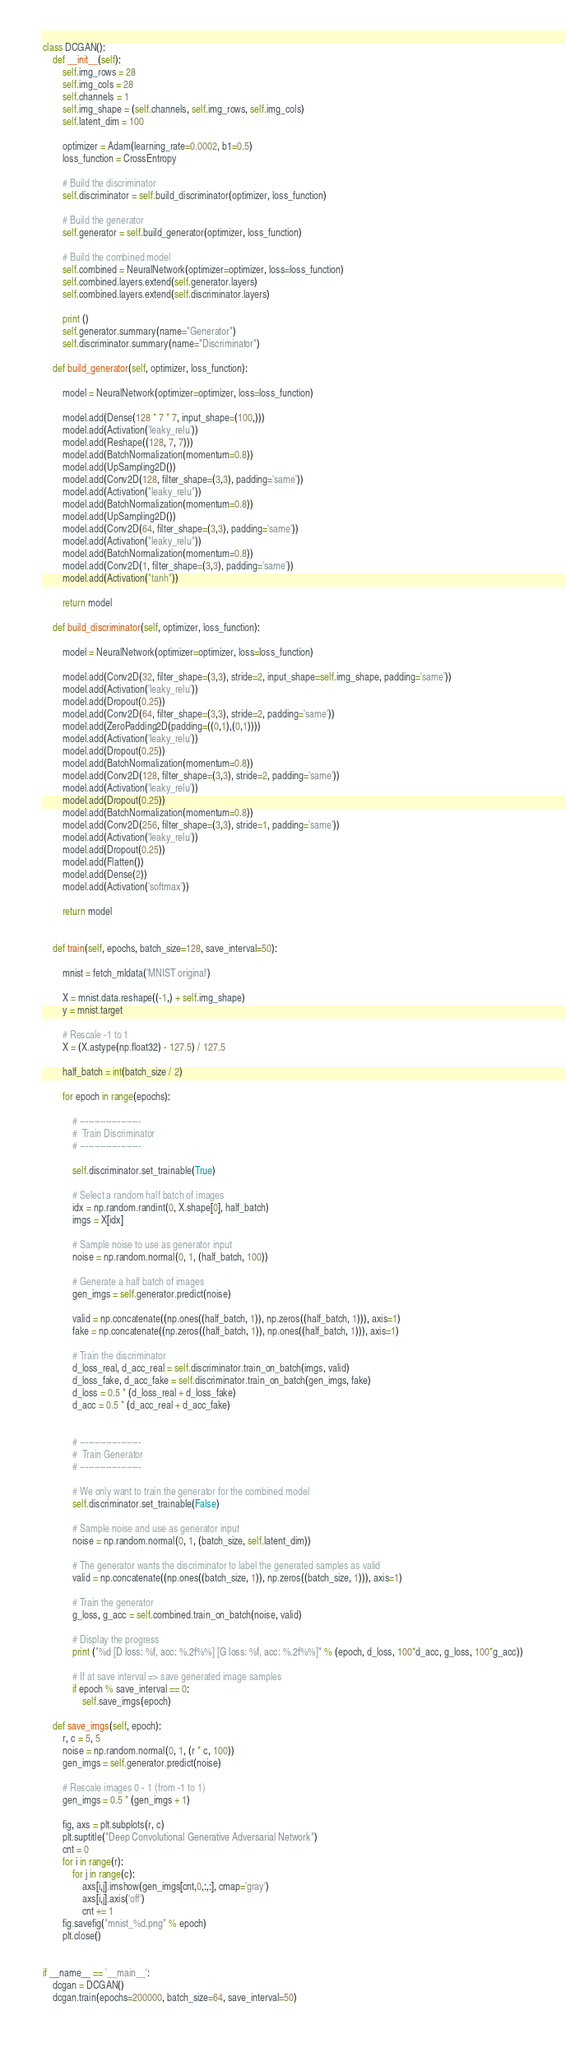Convert code to text. <code><loc_0><loc_0><loc_500><loc_500><_Python_>

class DCGAN():
    def __init__(self):
        self.img_rows = 28 
        self.img_cols = 28
        self.channels = 1
        self.img_shape = (self.channels, self.img_rows, self.img_cols)
        self.latent_dim = 100

        optimizer = Adam(learning_rate=0.0002, b1=0.5)
        loss_function = CrossEntropy

        # Build the discriminator
        self.discriminator = self.build_discriminator(optimizer, loss_function)

        # Build the generator
        self.generator = self.build_generator(optimizer, loss_function)

        # Build the combined model
        self.combined = NeuralNetwork(optimizer=optimizer, loss=loss_function)
        self.combined.layers.extend(self.generator.layers)
        self.combined.layers.extend(self.discriminator.layers)

        print ()
        self.generator.summary(name="Generator")
        self.discriminator.summary(name="Discriminator")

    def build_generator(self, optimizer, loss_function):
        
        model = NeuralNetwork(optimizer=optimizer, loss=loss_function)

        model.add(Dense(128 * 7 * 7, input_shape=(100,)))
        model.add(Activation('leaky_relu'))
        model.add(Reshape((128, 7, 7)))
        model.add(BatchNormalization(momentum=0.8))
        model.add(UpSampling2D())
        model.add(Conv2D(128, filter_shape=(3,3), padding='same'))
        model.add(Activation("leaky_relu"))
        model.add(BatchNormalization(momentum=0.8))
        model.add(UpSampling2D())
        model.add(Conv2D(64, filter_shape=(3,3), padding='same'))
        model.add(Activation("leaky_relu"))
        model.add(BatchNormalization(momentum=0.8))
        model.add(Conv2D(1, filter_shape=(3,3), padding='same'))
        model.add(Activation("tanh"))

        return model

    def build_discriminator(self, optimizer, loss_function):
        
        model = NeuralNetwork(optimizer=optimizer, loss=loss_function)

        model.add(Conv2D(32, filter_shape=(3,3), stride=2, input_shape=self.img_shape, padding='same'))
        model.add(Activation('leaky_relu'))
        model.add(Dropout(0.25))
        model.add(Conv2D(64, filter_shape=(3,3), stride=2, padding='same'))
        model.add(ZeroPadding2D(padding=((0,1),(0,1))))
        model.add(Activation('leaky_relu'))
        model.add(Dropout(0.25))
        model.add(BatchNormalization(momentum=0.8))
        model.add(Conv2D(128, filter_shape=(3,3), stride=2, padding='same'))
        model.add(Activation('leaky_relu'))
        model.add(Dropout(0.25))
        model.add(BatchNormalization(momentum=0.8))
        model.add(Conv2D(256, filter_shape=(3,3), stride=1, padding='same'))
        model.add(Activation('leaky_relu'))
        model.add(Dropout(0.25))
        model.add(Flatten())
        model.add(Dense(2))
        model.add(Activation('softmax'))

        return model


    def train(self, epochs, batch_size=128, save_interval=50):

        mnist = fetch_mldata('MNIST original')

        X = mnist.data.reshape((-1,) + self.img_shape)
        y = mnist.target

        # Rescale -1 to 1
        X = (X.astype(np.float32) - 127.5) / 127.5

        half_batch = int(batch_size / 2)

        for epoch in range(epochs):

            # ---------------------
            #  Train Discriminator
            # ---------------------

            self.discriminator.set_trainable(True)

            # Select a random half batch of images
            idx = np.random.randint(0, X.shape[0], half_batch)
            imgs = X[idx]

            # Sample noise to use as generator input
            noise = np.random.normal(0, 1, (half_batch, 100))

            # Generate a half batch of images
            gen_imgs = self.generator.predict(noise)

            valid = np.concatenate((np.ones((half_batch, 1)), np.zeros((half_batch, 1))), axis=1)
            fake = np.concatenate((np.zeros((half_batch, 1)), np.ones((half_batch, 1))), axis=1)

            # Train the discriminator
            d_loss_real, d_acc_real = self.discriminator.train_on_batch(imgs, valid)
            d_loss_fake, d_acc_fake = self.discriminator.train_on_batch(gen_imgs, fake)
            d_loss = 0.5 * (d_loss_real + d_loss_fake)
            d_acc = 0.5 * (d_acc_real + d_acc_fake)


            # ---------------------
            #  Train Generator
            # ---------------------

            # We only want to train the generator for the combined model
            self.discriminator.set_trainable(False)

            # Sample noise and use as generator input
            noise = np.random.normal(0, 1, (batch_size, self.latent_dim))

            # The generator wants the discriminator to label the generated samples as valid
            valid = np.concatenate((np.ones((batch_size, 1)), np.zeros((batch_size, 1))), axis=1)

            # Train the generator
            g_loss, g_acc = self.combined.train_on_batch(noise, valid)

            # Display the progress
            print ("%d [D loss: %f, acc: %.2f%%] [G loss: %f, acc: %.2f%%]" % (epoch, d_loss, 100*d_acc, g_loss, 100*g_acc))

            # If at save interval => save generated image samples
            if epoch % save_interval == 0:
                self.save_imgs(epoch)

    def save_imgs(self, epoch):
        r, c = 5, 5
        noise = np.random.normal(0, 1, (r * c, 100))
        gen_imgs = self.generator.predict(noise)

        # Rescale images 0 - 1 (from -1 to 1)
        gen_imgs = 0.5 * (gen_imgs + 1)

        fig, axs = plt.subplots(r, c)
        plt.suptitle("Deep Convolutional Generative Adversarial Network")
        cnt = 0
        for i in range(r):
            for j in range(c):
                axs[i,j].imshow(gen_imgs[cnt,0,:,:], cmap='gray')
                axs[i,j].axis('off')
                cnt += 1
        fig.savefig("mnist_%d.png" % epoch)
        plt.close()


if __name__ == '__main__':
    dcgan = DCGAN()
    dcgan.train(epochs=200000, batch_size=64, save_interval=50)


</code> 